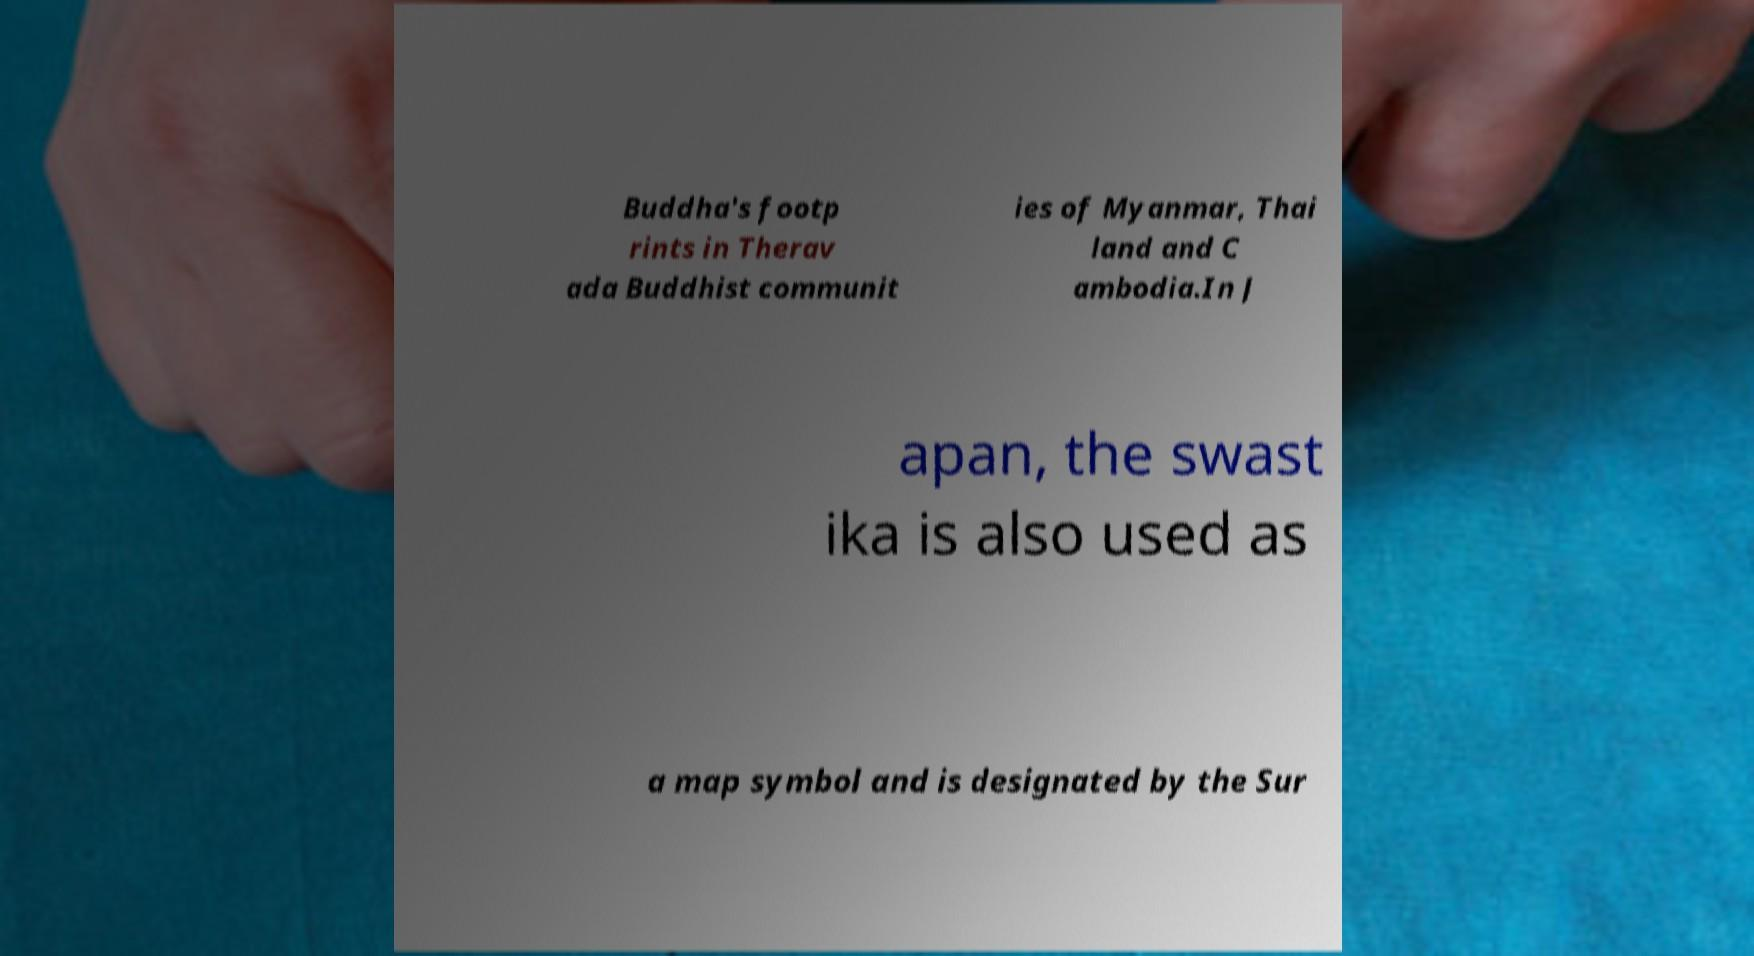There's text embedded in this image that I need extracted. Can you transcribe it verbatim? Buddha's footp rints in Therav ada Buddhist communit ies of Myanmar, Thai land and C ambodia.In J apan, the swast ika is also used as a map symbol and is designated by the Sur 